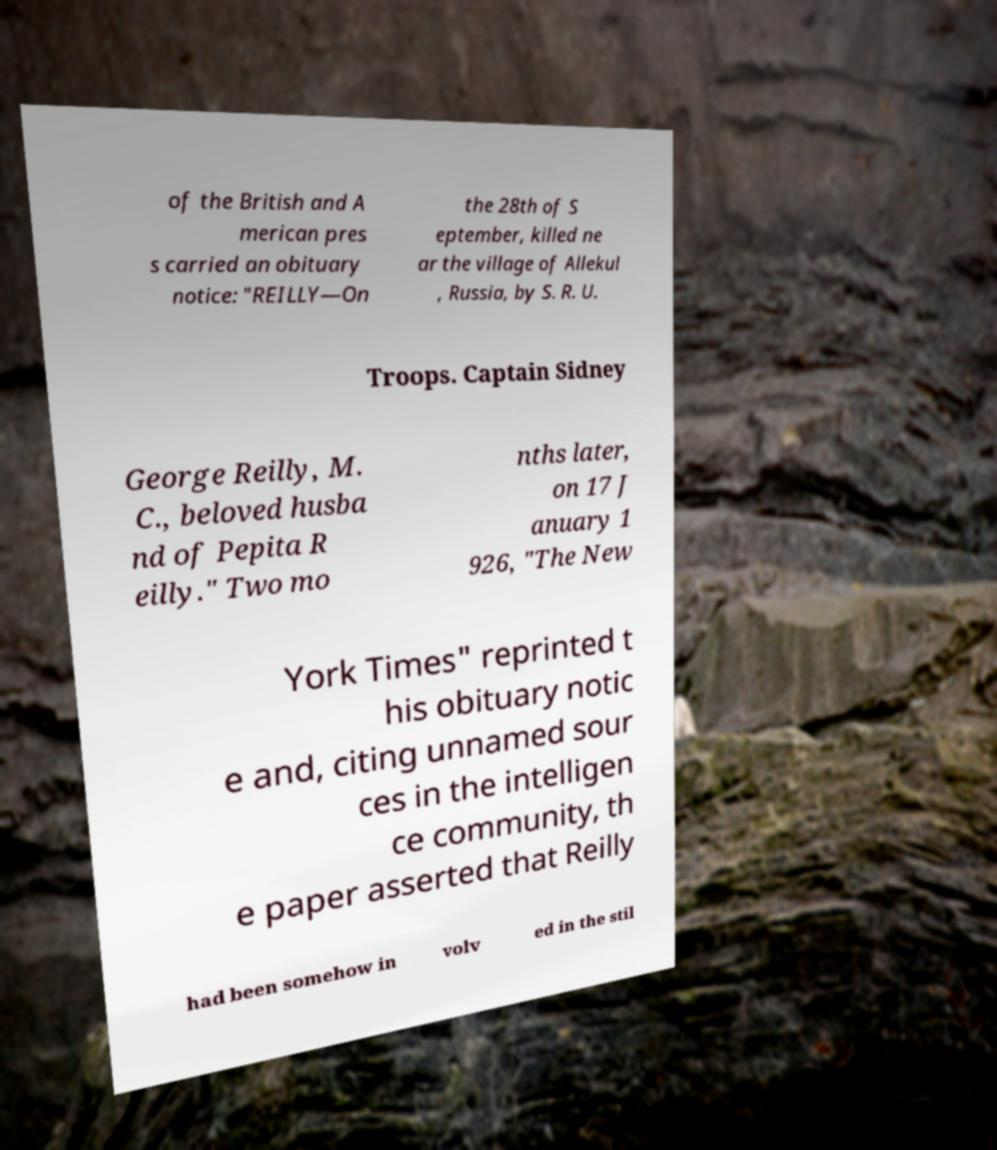There's text embedded in this image that I need extracted. Can you transcribe it verbatim? of the British and A merican pres s carried an obituary notice: "REILLY—On the 28th of S eptember, killed ne ar the village of Allekul , Russia, by S. R. U. Troops. Captain Sidney George Reilly, M. C., beloved husba nd of Pepita R eilly." Two mo nths later, on 17 J anuary 1 926, "The New York Times" reprinted t his obituary notic e and, citing unnamed sour ces in the intelligen ce community, th e paper asserted that Reilly had been somehow in volv ed in the stil 